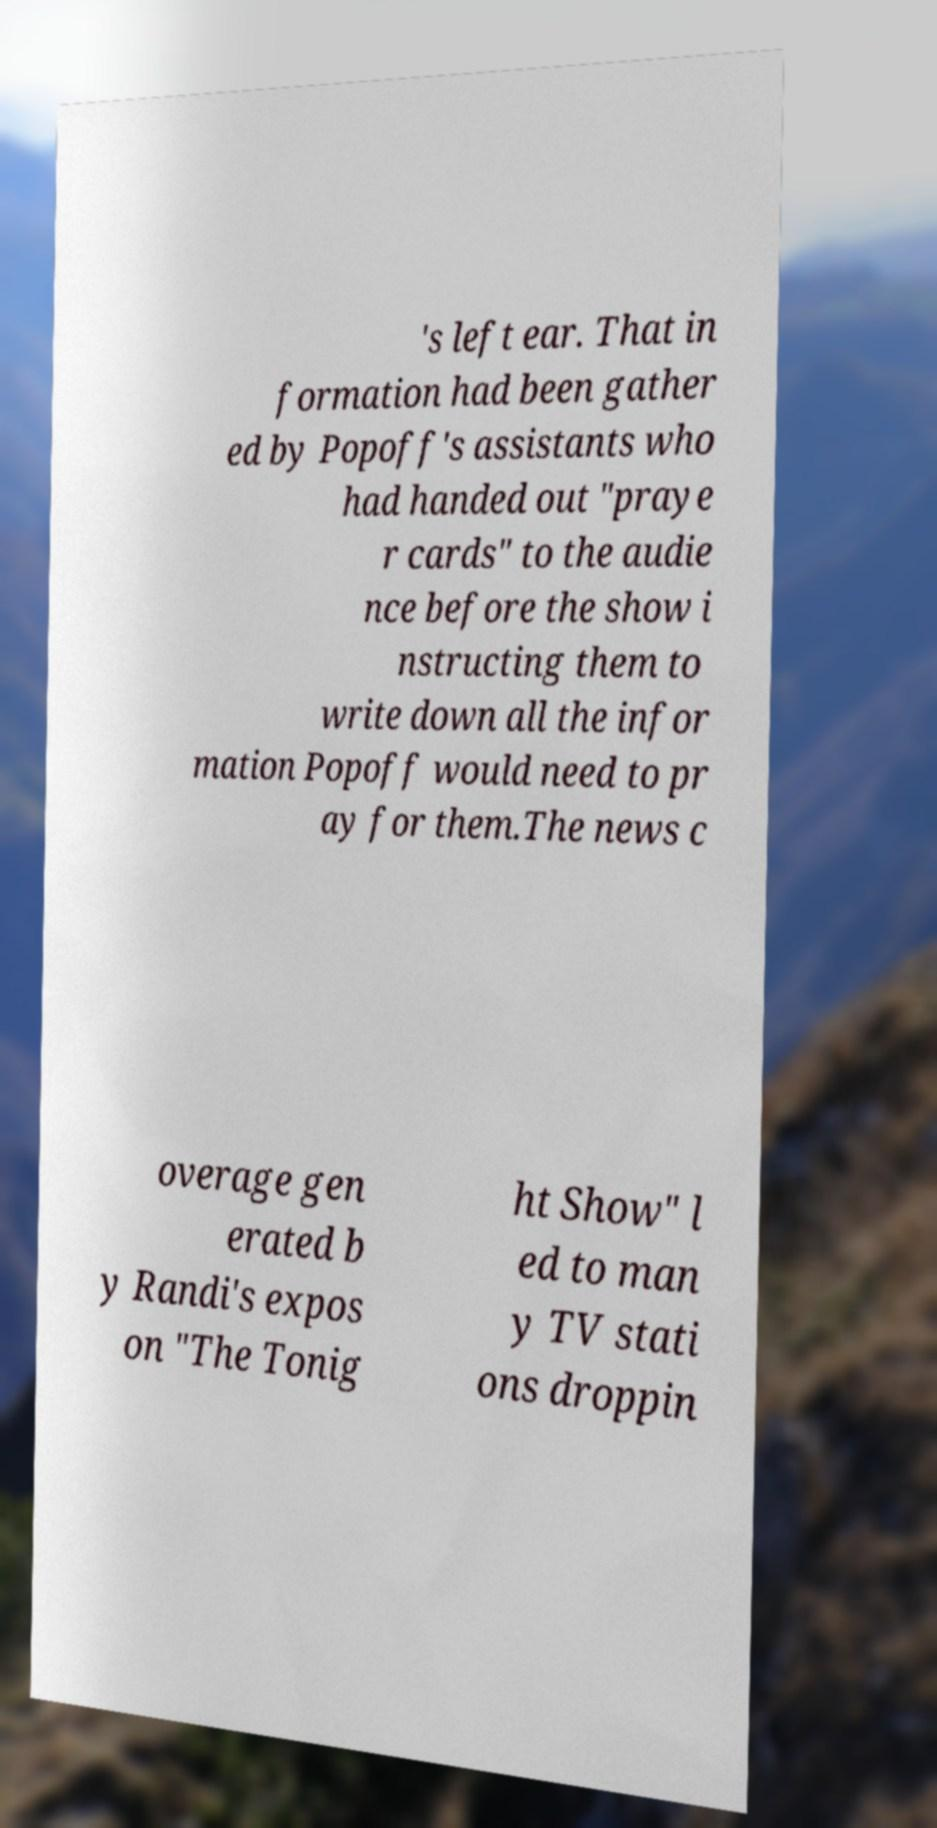Please read and relay the text visible in this image. What does it say? 's left ear. That in formation had been gather ed by Popoff's assistants who had handed out "praye r cards" to the audie nce before the show i nstructing them to write down all the infor mation Popoff would need to pr ay for them.The news c overage gen erated b y Randi's expos on "The Tonig ht Show" l ed to man y TV stati ons droppin 